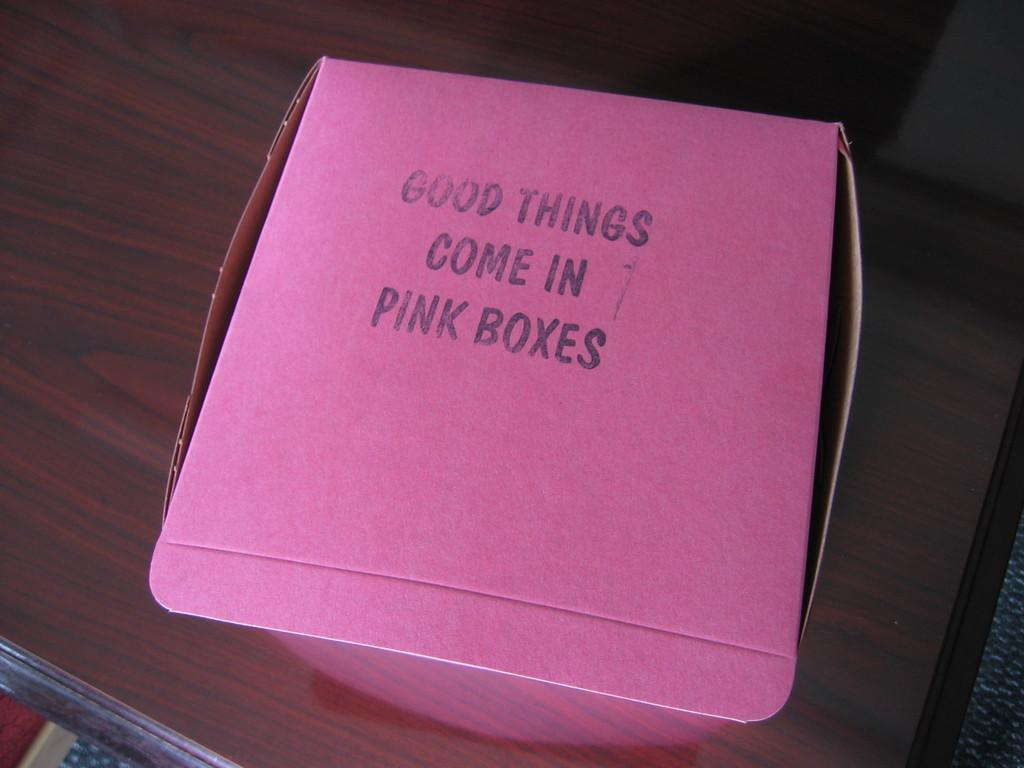<image>
Present a compact description of the photo's key features. a pink box that has a stamp of the words 'good things come in pink boxes' 